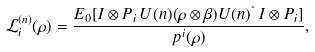Convert formula to latex. <formula><loc_0><loc_0><loc_500><loc_500>\mathcal { L } ^ { ( n ) } _ { i } ( \rho ) = \frac { E _ { 0 } [ I \otimes P _ { i } \, U ( n ) ( \rho \otimes \beta ) U ( n ) ^ { ^ { * } } \, I \otimes P _ { i } ] } { p ^ { i } ( \rho ) } ,</formula> 